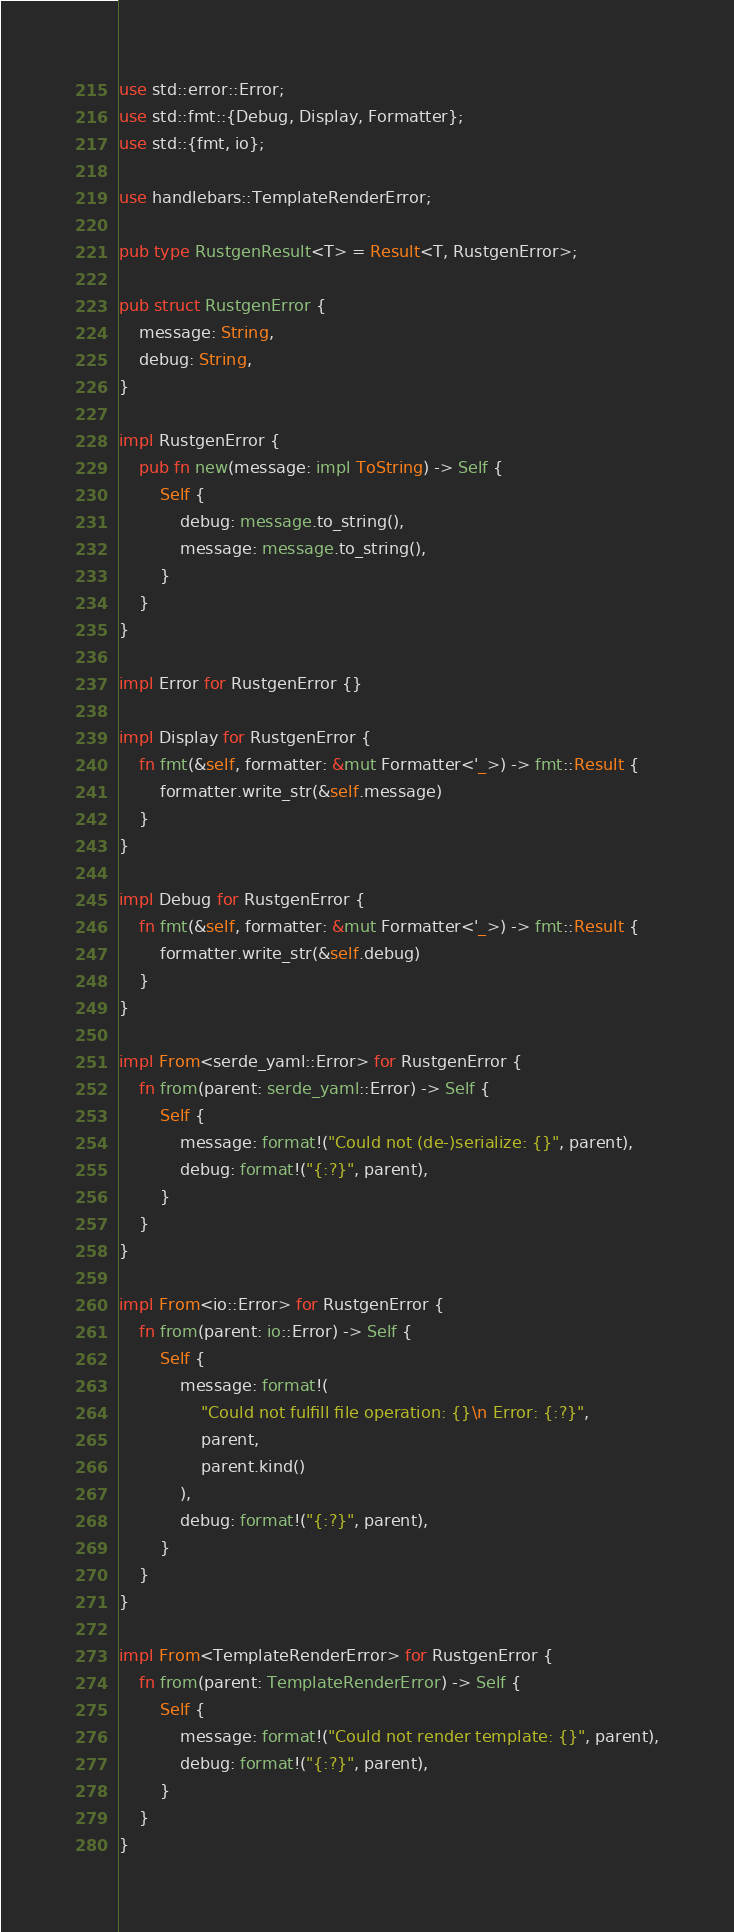Convert code to text. <code><loc_0><loc_0><loc_500><loc_500><_Rust_>use std::error::Error;
use std::fmt::{Debug, Display, Formatter};
use std::{fmt, io};

use handlebars::TemplateRenderError;

pub type RustgenResult<T> = Result<T, RustgenError>;

pub struct RustgenError {
    message: String,
    debug: String,
}

impl RustgenError {
    pub fn new(message: impl ToString) -> Self {
        Self {
            debug: message.to_string(),
            message: message.to_string(),
        }
    }
}

impl Error for RustgenError {}

impl Display for RustgenError {
    fn fmt(&self, formatter: &mut Formatter<'_>) -> fmt::Result {
        formatter.write_str(&self.message)
    }
}

impl Debug for RustgenError {
    fn fmt(&self, formatter: &mut Formatter<'_>) -> fmt::Result {
        formatter.write_str(&self.debug)
    }
}

impl From<serde_yaml::Error> for RustgenError {
    fn from(parent: serde_yaml::Error) -> Self {
        Self {
            message: format!("Could not (de-)serialize: {}", parent),
            debug: format!("{:?}", parent),
        }
    }
}

impl From<io::Error> for RustgenError {
    fn from(parent: io::Error) -> Self {
        Self {
            message: format!(
                "Could not fulfill file operation: {}\n Error: {:?}",
                parent,
                parent.kind()
            ),
            debug: format!("{:?}", parent),
        }
    }
}

impl From<TemplateRenderError> for RustgenError {
    fn from(parent: TemplateRenderError) -> Self {
        Self {
            message: format!("Could not render template: {}", parent),
            debug: format!("{:?}", parent),
        }
    }
}
</code> 